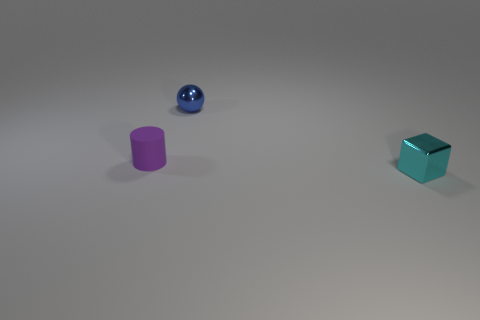There is a metal object that is in front of the tiny purple rubber thing; what is its shape? cube 